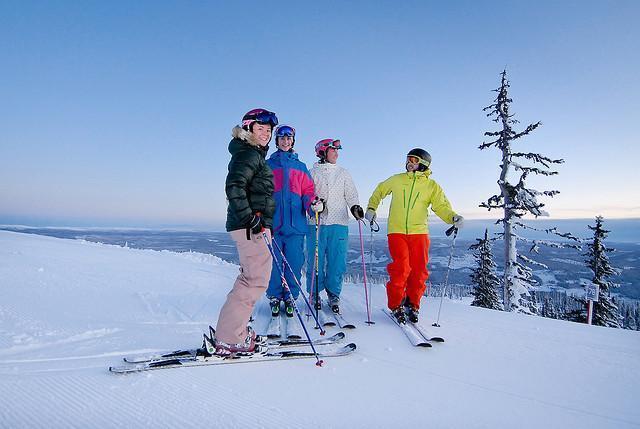Why are they stopped?
Answer the question by selecting the correct answer among the 4 following choices and explain your choice with a short sentence. The answer should be formatted with the following format: `Answer: choice
Rationale: rationale.`
Options: Eating lunch, lost, resting, at summit. Answer: at summit.
Rationale: There is nowhere higher for these people to ski to or from. 